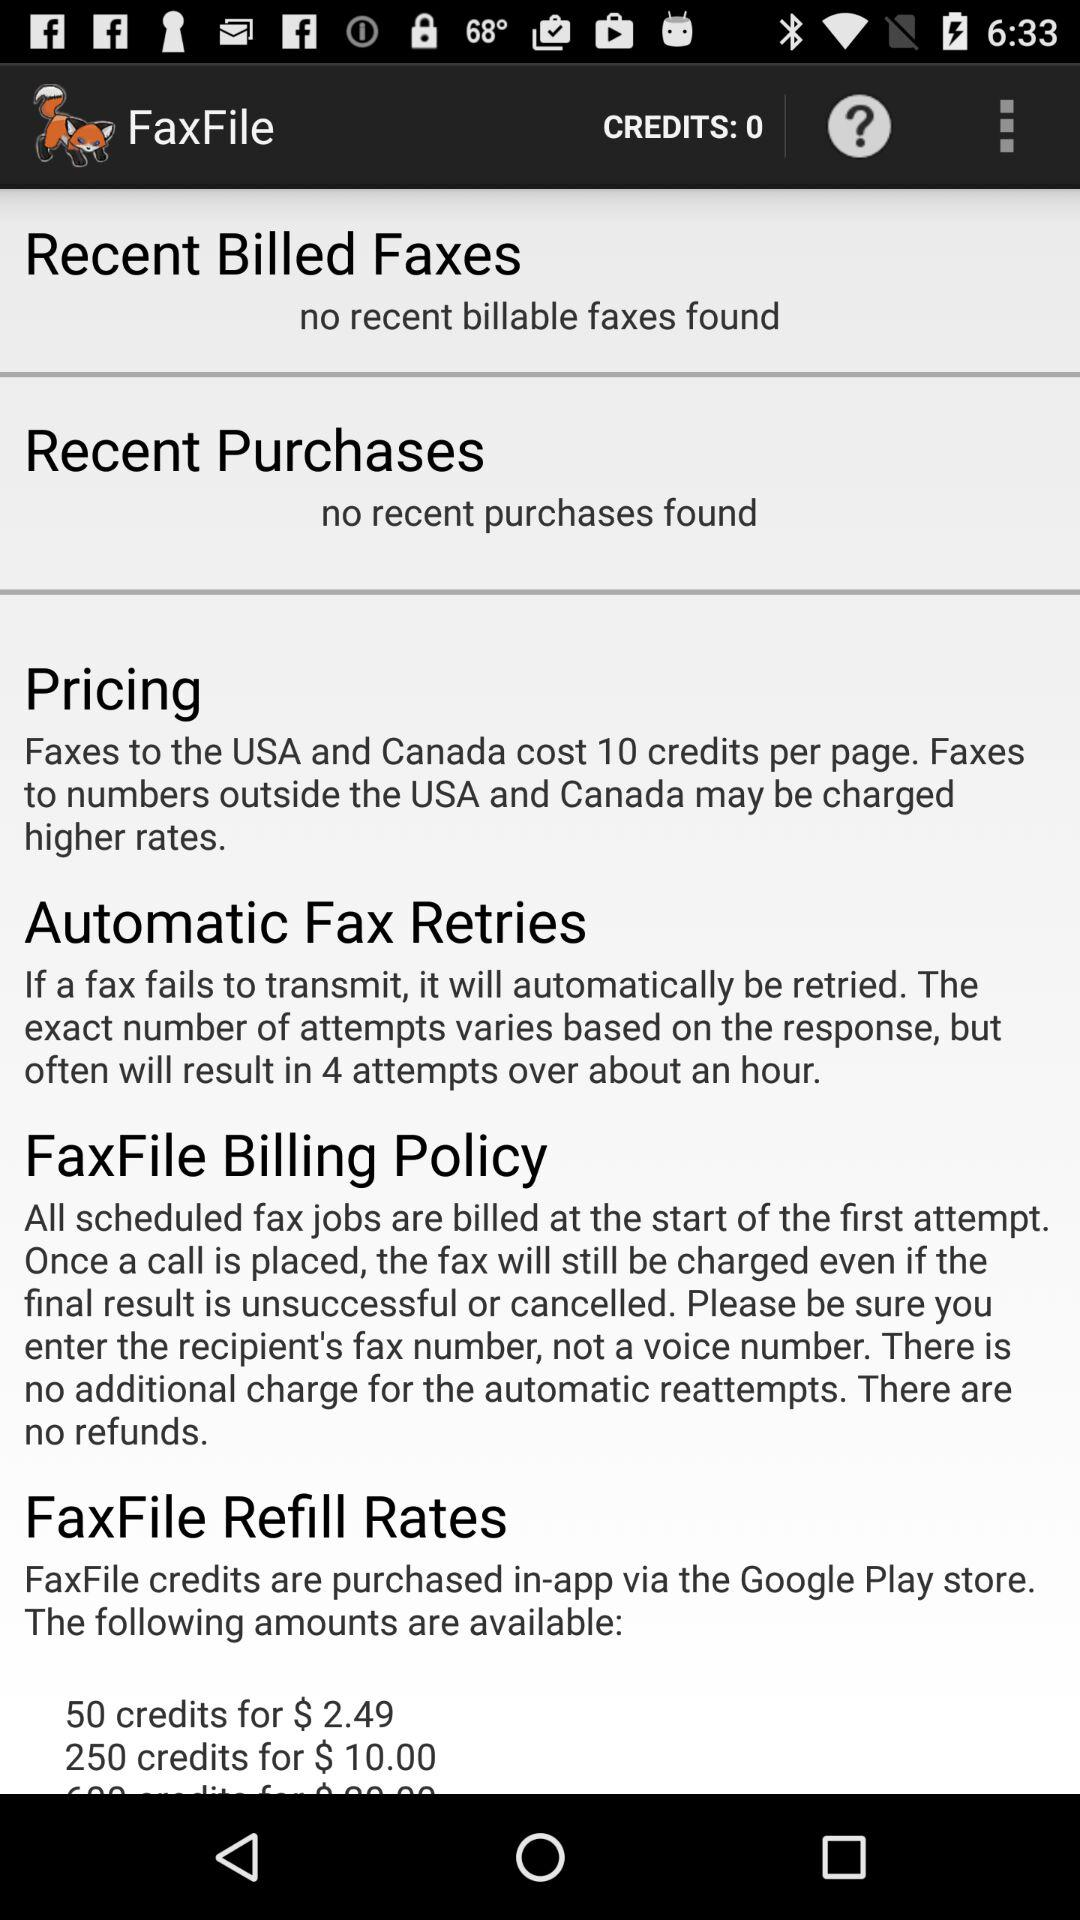Is there any "Recent Purchases"? There are no recent purchases. 